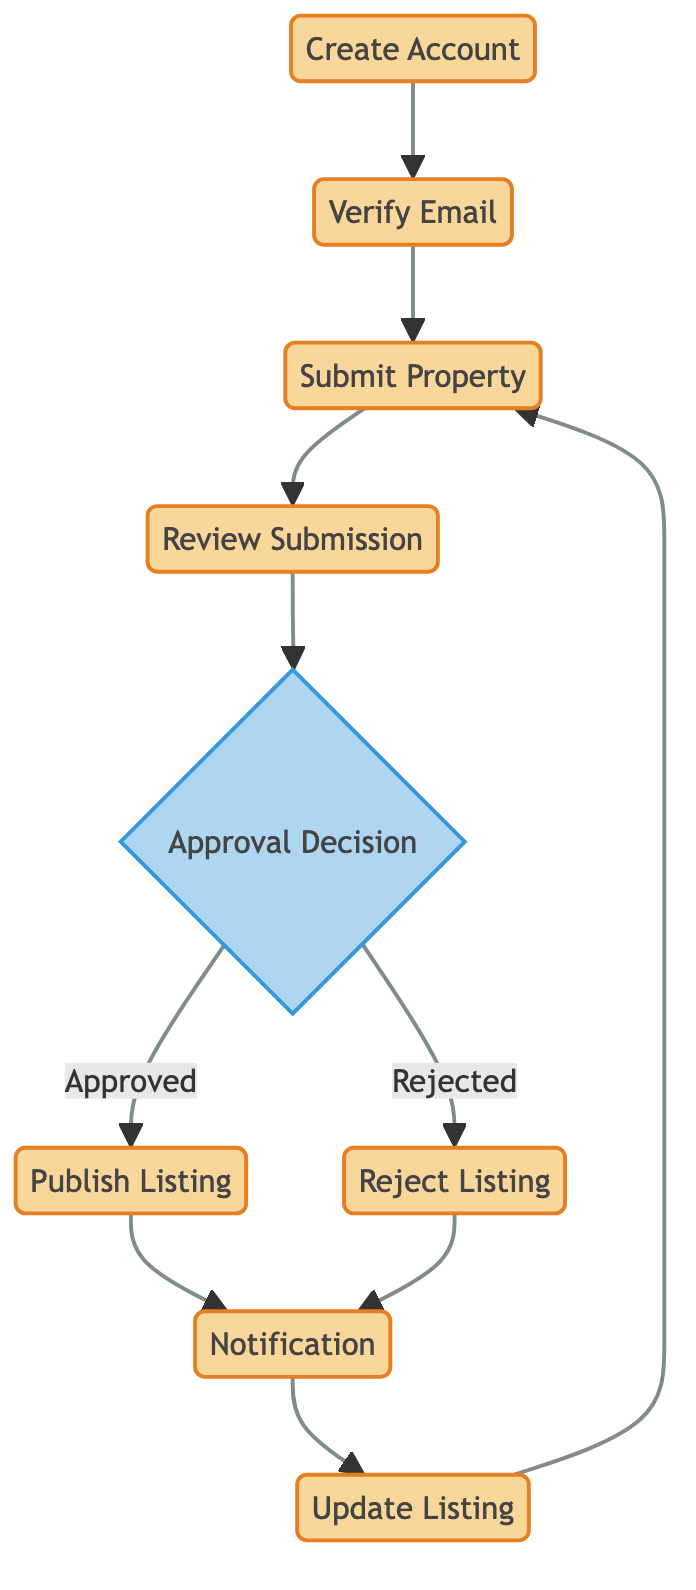What is the first step in the property listing workflow? The first step involves the user creating an account. The flow starts with the "Create Account" node at the bottom of the diagram, indicating this as the first action in the workflow.
Answer: Create Account How many process nodes are in the diagram? By counting the process nodes, we find that there are six: Create Account, Verify Email, Submit Property, Review Submission, Publish Listing, Reject Listing, Notification, and Update Listing. Therefore, there are seven in total.
Answer: Seven What happens after a property is submitted? After a property is submitted, it moves to the "Review Submission" process, where the details of the property are reviewed. This is the next node immediately following "Submit Property" in the diagram.
Answer: Review Submission What decision might follow the review submission step? After reviewing the submission, the next step is the "Approval Decision," where a decision is made to approve or reject the listing based on the review. This decision node directly follows the review process.
Answer: Approval Decision If a listing is rejected, what is the next step? After a listing is rejected, the next action is to send a notification to the seller or agent about the rejection and possible reasons, which corresponds to the "Notification" process node.
Answer: Notification How does the workflow proceed if the listing is approved? If the listing is approved, it goes directly to the "Publish Listing" process, making the property visible to potential buyers. The flow from "Approval Decision" to "Publish Listing" maps this path clearly in the diagram.
Answer: Publish Listing What must a user do to access the platform? A user must verify their email address to gain access to the platform, as indicated by the "Verify Email" process node, which follows the account creation step.
Answer: Verify Email What happens if modifications to the listing are needed? If any modifications are needed, the workflow indicates that the seller or agent will update the listing, which is represented by the "Update Listing" process. This is a subsequent step after receiving the notification.
Answer: Update Listing What type of nodes are used to represent decision points in the diagram? The decision points in the diagram are represented by diamond-shaped nodes, referred to as decision nodes. In this specific diagram, the "Approval Decision" node serves as the sole decision point.
Answer: Decision nodes 